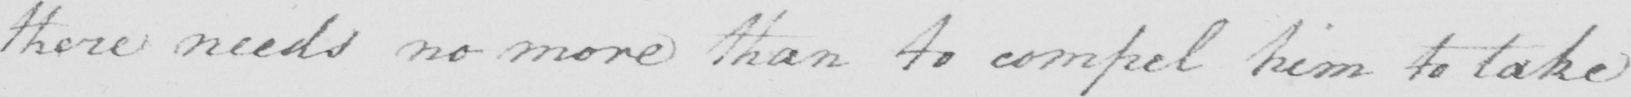What text is written in this handwritten line? there needs no more than to compel him to take 